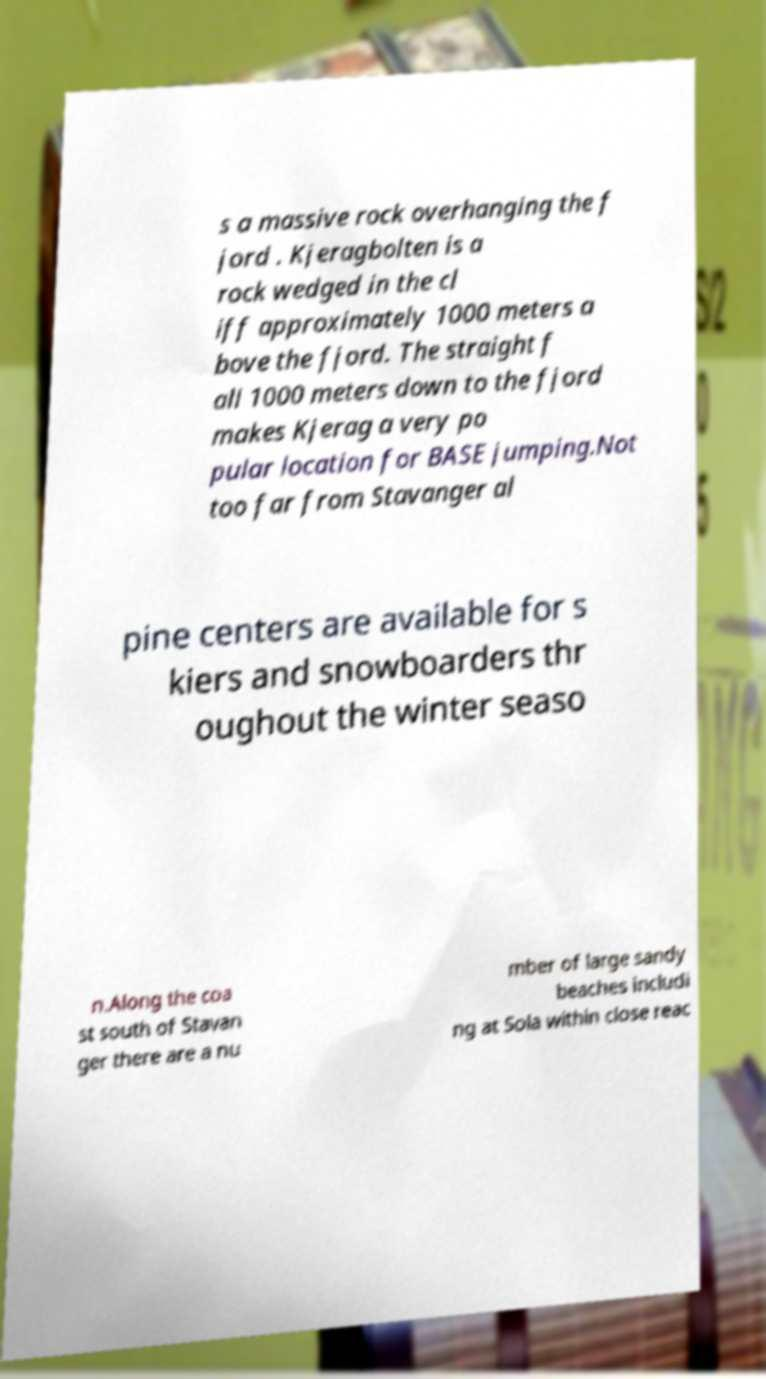For documentation purposes, I need the text within this image transcribed. Could you provide that? s a massive rock overhanging the f jord . Kjeragbolten is a rock wedged in the cl iff approximately 1000 meters a bove the fjord. The straight f all 1000 meters down to the fjord makes Kjerag a very po pular location for BASE jumping.Not too far from Stavanger al pine centers are available for s kiers and snowboarders thr oughout the winter seaso n.Along the coa st south of Stavan ger there are a nu mber of large sandy beaches includi ng at Sola within close reac 